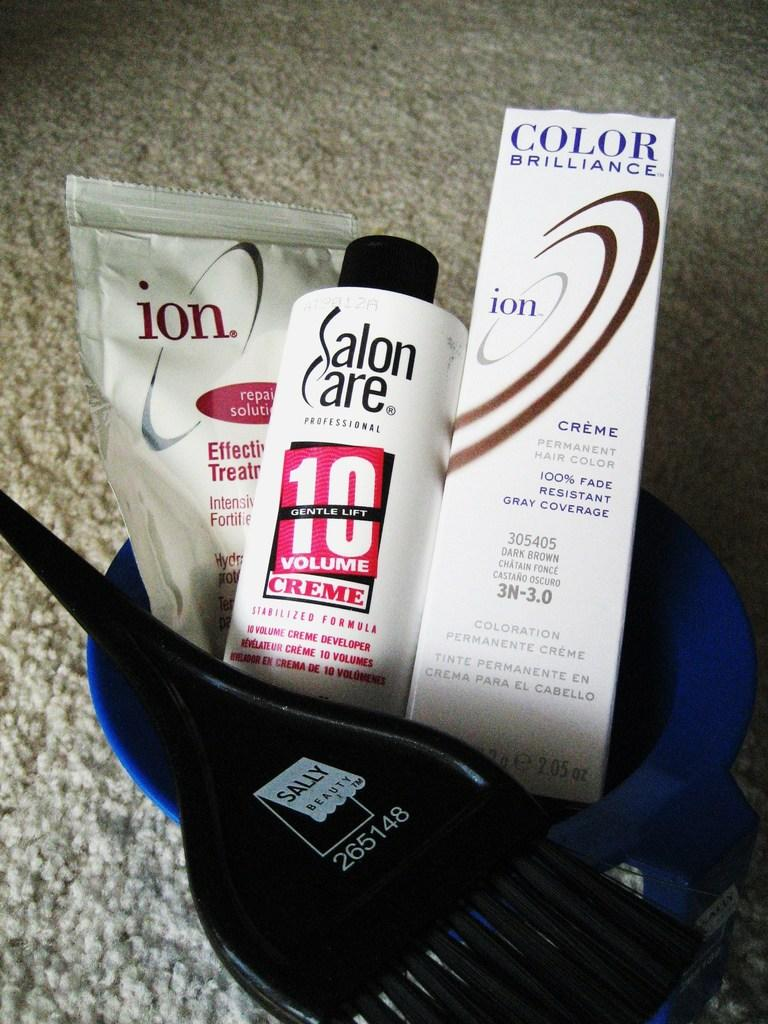<image>
Give a short and clear explanation of the subsequent image. A few beauty products such as Salon Care cream 